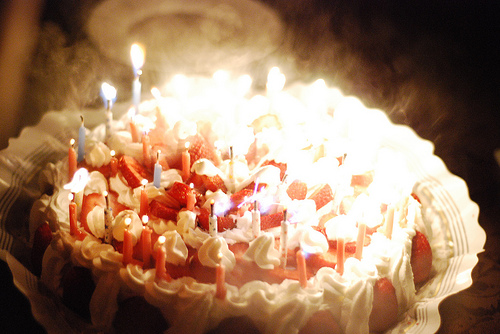<image>
Is there a fire on the candle? No. The fire is not positioned on the candle. They may be near each other, but the fire is not supported by or resting on top of the candle. Is there a candle next to the frosting? Yes. The candle is positioned adjacent to the frosting, located nearby in the same general area. 